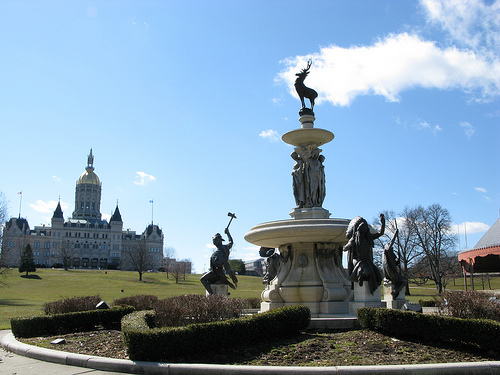<image>
Can you confirm if the dear is on the sky? No. The dear is not positioned on the sky. They may be near each other, but the dear is not supported by or resting on top of the sky. 